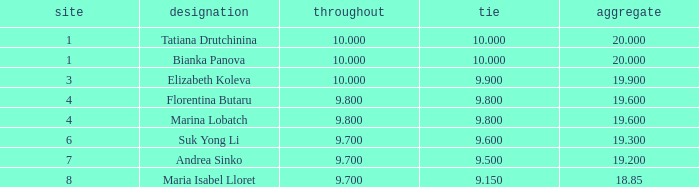Would you be able to parse every entry in this table? {'header': ['site', 'designation', 'throughout', 'tie', 'aggregate'], 'rows': [['1', 'Tatiana Drutchinina', '10.000', '10.000', '20.000'], ['1', 'Bianka Panova', '10.000', '10.000', '20.000'], ['3', 'Elizabeth Koleva', '10.000', '9.900', '19.900'], ['4', 'Florentina Butaru', '9.800', '9.800', '19.600'], ['4', 'Marina Lobatch', '9.800', '9.800', '19.600'], ['6', 'Suk Yong Li', '9.700', '9.600', '19.300'], ['7', 'Andrea Sinko', '9.700', '9.500', '19.200'], ['8', 'Maria Isabel Lloret', '9.700', '9.150', '18.85']]} 8 and a 1 7.0. 